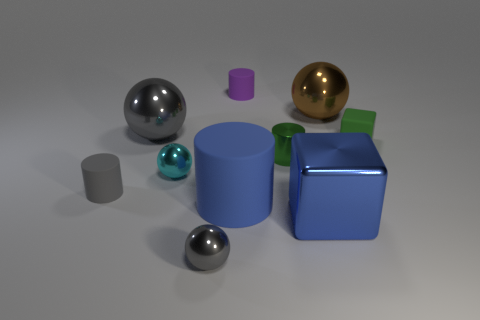Subtract all cylinders. How many objects are left? 6 Subtract all gray matte cubes. Subtract all matte objects. How many objects are left? 6 Add 3 large shiny cubes. How many large shiny cubes are left? 4 Add 2 small brown cylinders. How many small brown cylinders exist? 2 Subtract 0 purple blocks. How many objects are left? 10 